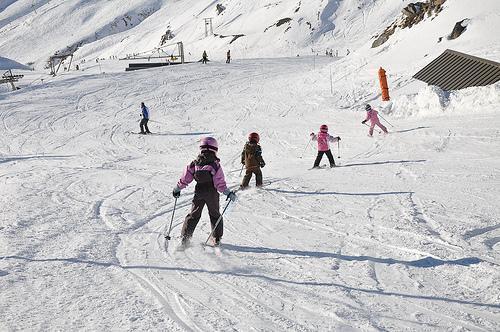How many poles is the person holding?
Give a very brief answer. 2. How many people are skiing?
Give a very brief answer. 5. 